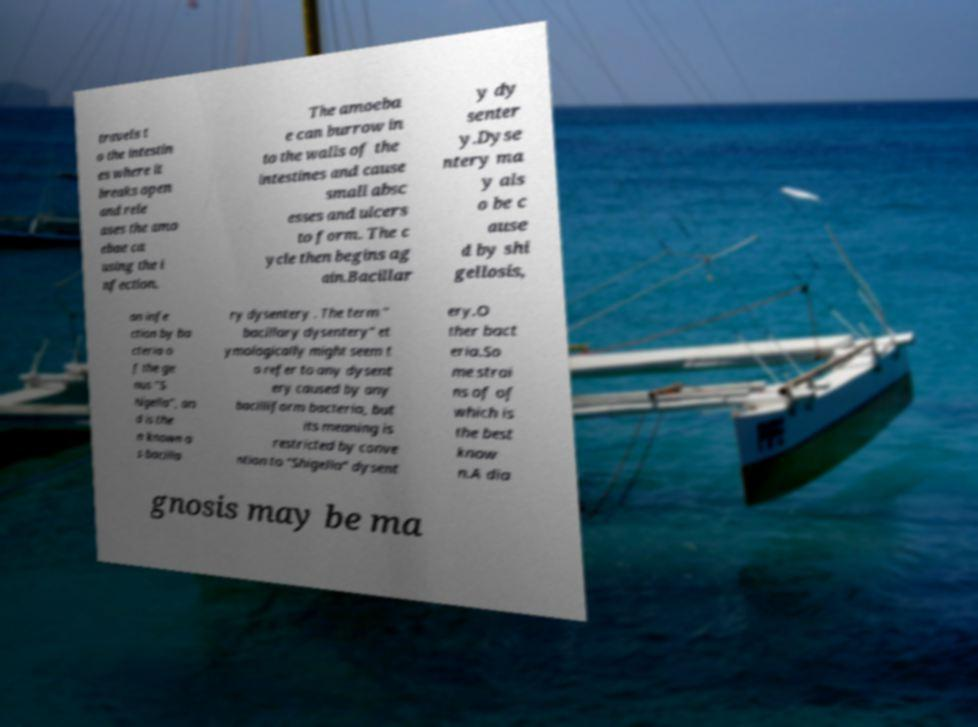Can you read and provide the text displayed in the image?This photo seems to have some interesting text. Can you extract and type it out for me? travels t o the intestin es where it breaks open and rele ases the amo ebae ca using the i nfection. The amoeba e can burrow in to the walls of the intestines and cause small absc esses and ulcers to form. The c ycle then begins ag ain.Bacillar y dy senter y.Dyse ntery ma y als o be c ause d by shi gellosis, an infe ction by ba cteria o f the ge nus "S higella", an d is the n known a s bacilla ry dysentery . The term " bacillary dysentery" et ymologically might seem t o refer to any dysent ery caused by any bacilliform bacteria, but its meaning is restricted by conve ntion to "Shigella" dysent ery.O ther bact eria.So me strai ns of of which is the best know n.A dia gnosis may be ma 